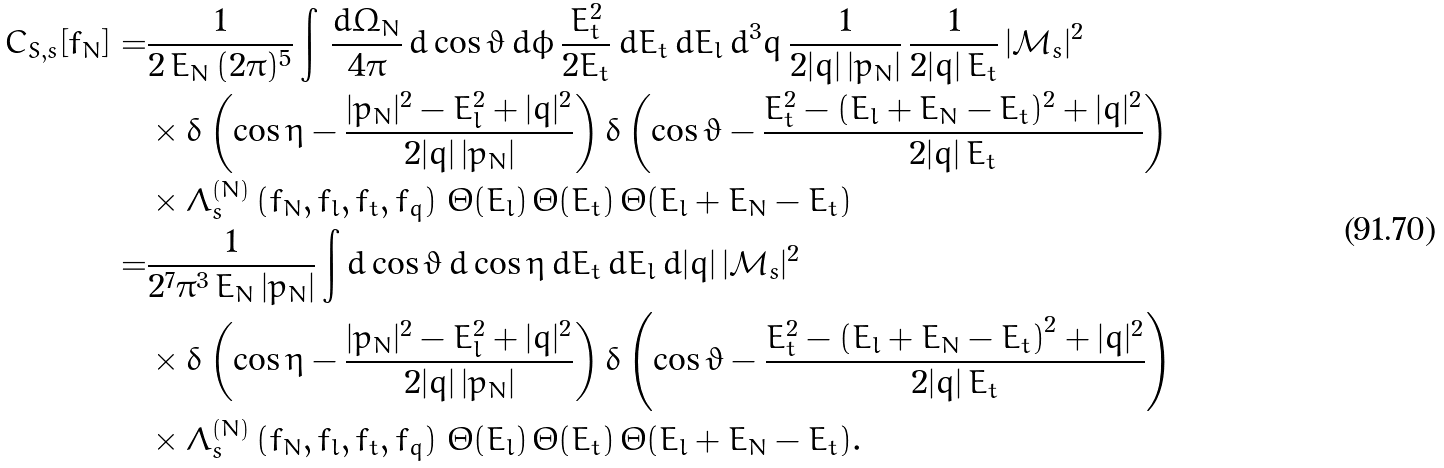<formula> <loc_0><loc_0><loc_500><loc_500>C _ { S , s } [ f _ { N } ] = & \frac { 1 } { 2 \, E _ { N } \, ( 2 \pi ) ^ { 5 } } \int \, \frac { d \Omega _ { N } } { 4 \pi } \, d \cos \vartheta \, d \phi \, \frac { E ^ { 2 } _ { t } } { 2 E _ { t } } \, d E _ { t } \, d E _ { l } \, d ^ { 3 } q \, \frac { 1 } { 2 | q | \, | p _ { N } | } \, \frac { 1 } { 2 | q | \, E _ { t } } \, | \mathcal { M } _ { s } | ^ { 2 } \\ & \times \delta \left ( \cos \eta - \frac { | p _ { N } | ^ { 2 } - E _ { l } ^ { 2 } + | q | ^ { 2 } } { 2 | q | \, | p _ { N } | } \right ) \delta \left ( \cos \vartheta - \frac { E ^ { 2 } _ { t } - ( E _ { l } + E _ { N } - E _ { t } ) ^ { 2 } + | q | ^ { 2 } } { 2 | q | \, E _ { t } } \right ) \\ & \times \Lambda _ { s } ^ { ( N ) } \left ( f _ { N } , f _ { l } , f _ { t } , f _ { q } \right ) \, \Theta ( E _ { l } ) \, \Theta ( E _ { t } ) \, \Theta ( E _ { l } + E _ { N } - E _ { t } ) \\ = & \frac { 1 } { 2 ^ { 7 } \pi ^ { 3 } \, E _ { N } \, | p _ { N } | } \int d \cos \vartheta \, d \cos \eta \, d E _ { t } \, d E _ { l } \, d | q | \, | \mathcal { M } _ { s } | ^ { 2 } \\ & \times \delta \left ( \cos \eta - \frac { | p _ { N } | ^ { 2 } - E _ { l } ^ { 2 } + | q | ^ { 2 } } { 2 | q | \, | p _ { N } | } \right ) \delta \left ( \cos \vartheta - \frac { E _ { t } ^ { 2 } - \left ( E _ { l } + E _ { N } - E _ { t } \right ) ^ { 2 } + | q | ^ { 2 } } { 2 | q | \, E _ { t } } \right ) \\ & \times \Lambda _ { s } ^ { ( N ) } \left ( f _ { N } , f _ { l } , f _ { t } , f _ { q } \right ) \, \Theta ( E _ { l } ) \, \Theta ( E _ { t } ) \, \Theta ( E _ { l } + E _ { N } - E _ { t } ) .</formula> 